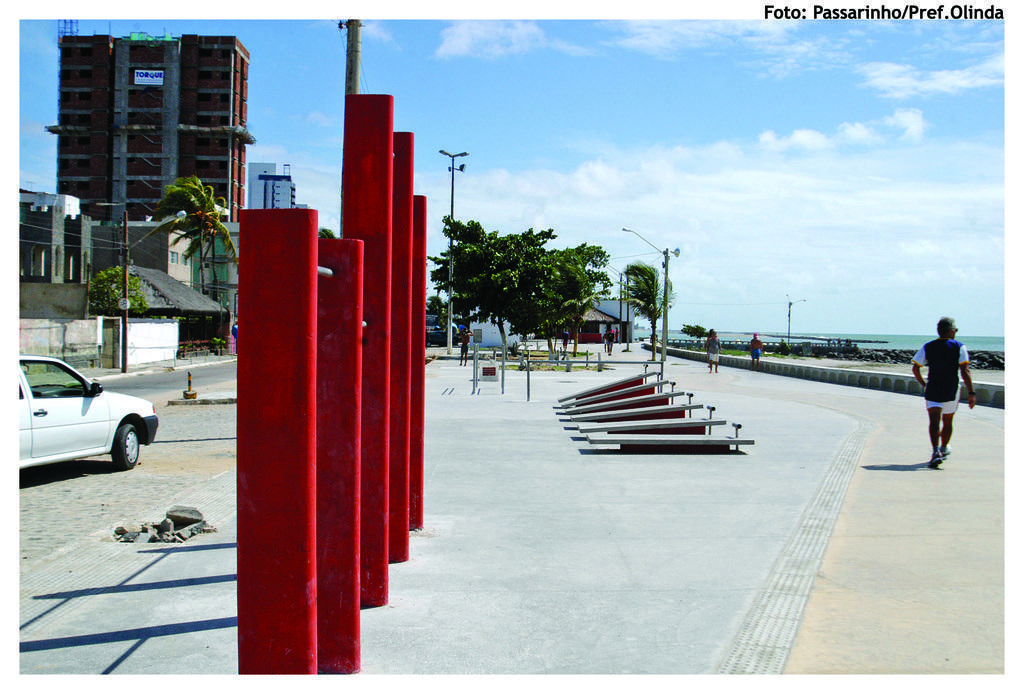Describe this image in one or two sentences. In the foreground I can see fence, metal rods, grass, group of people, trees and vehicles on the road. In the background I can see buildings, wires, poles, water and the sky. This image is taken may be on the road. 